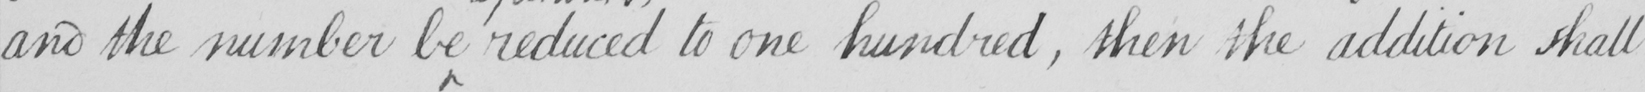What is written in this line of handwriting? and the number be reduced to one hundred , then the addition shall 